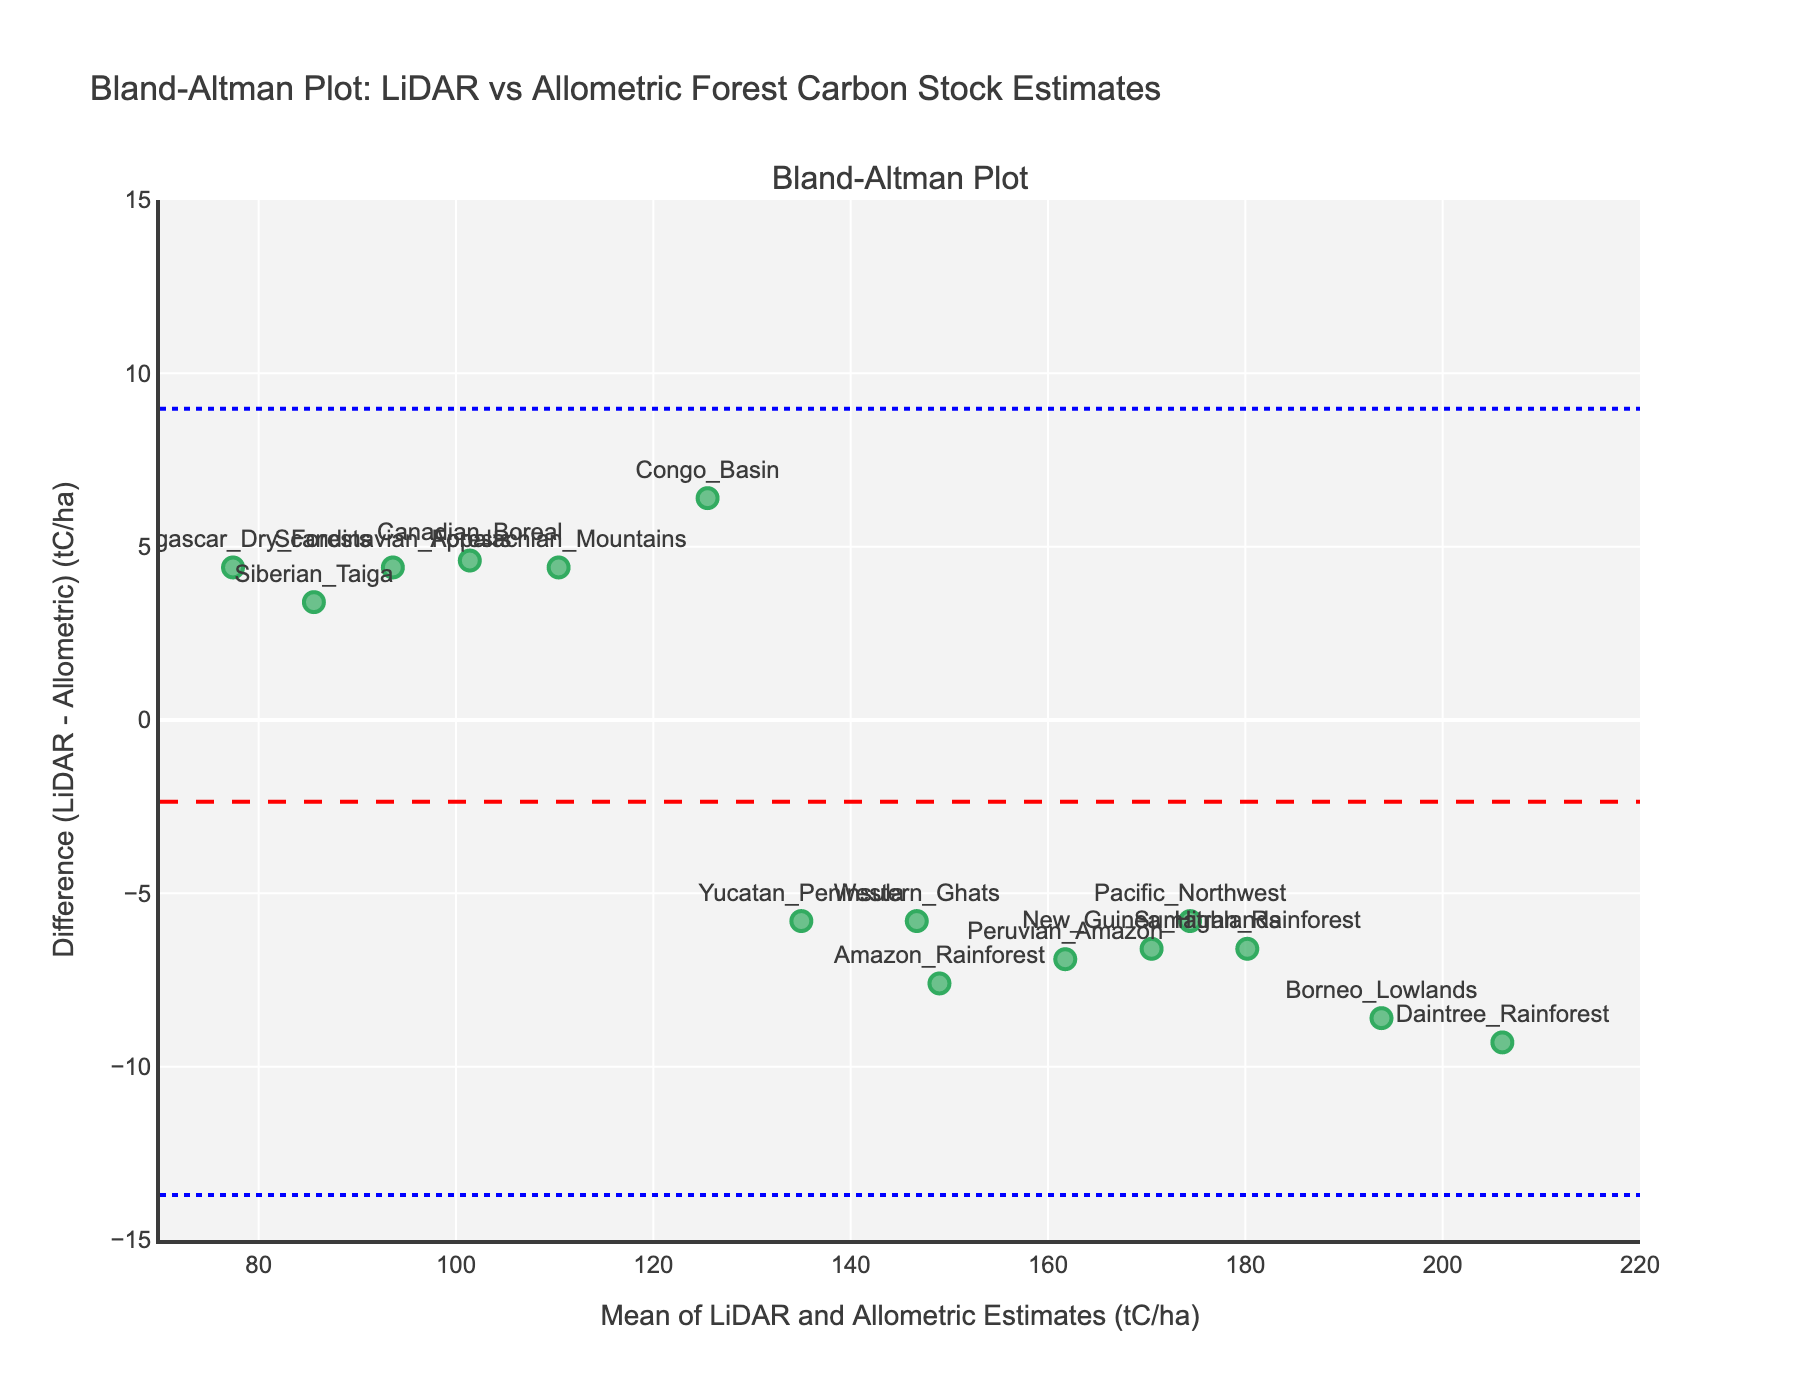How many data points are shown on the plot? Count the number of markers representing different forest locations on the plot. Each marker represents one data point.
Answer: 15 What is the title of the plot? Look at the text at the top of the plot. It's typically larger and bold to distinguish it as the title.
Answer: Bland-Altman Plot: LiDAR vs Allometric Forest Carbon Stock Estimates Which region has the highest mean value of LiDAR and Allometric estimates? Identify the x-axis positions of the markers. The marker farthest to the right on the x-axis has the highest mean value of LiDAR and Allometric estimates.
Answer: Daintree Rainforest What is the mean difference between LiDAR and Allometric estimates? Find the dashed red line on the y-axis. The value where this line intersects the y-axis is the mean difference.
Answer: Approximately -0.1 What are the upper and lower limits of agreement (LoA)? The dotted blue lines on the plot indicate the upper and lower limits of agreement. Read the y-axis values where these lines intersect.
Answer: Upper LoA: Approximately 5.9, Lower LoA: Approximately -6.1 Which forest region shows the largest positive difference between LiDAR and Allometric estimates? Identify the marker with the highest position above the x-axis, which indicates the largest positive difference.
Answer: Borneo Lowlands Which forest region shows the largest negative difference between LiDAR and Allometric estimates? Identify the marker with the lowest position below the x-axis, which indicates the largest negative difference.
Answer: Madagascar Dry Forests What is the average mean value of the methods (LiDAR and Allometric estimates) for the Amazon Rainforest and the Pacific Northwest? Calculate the mean value for Amazon Rainforest ((145.2 + 152.8) / 2) and for Pacific Northwest ((171.5 + 177.3) / 2), then find their average.
Answer: ((149.0 + 174.4) / 2) = 161.7 Is there any forest region where the LiDAR estimate is exactly equal to the Allometric estimate? Check the plot for any data point lying exactly on the x-axis where the difference would be zero.
Answer: No What is the range of mean values for all the data points? Identify the minimum and maximum x-axis values of the markers. The range is the difference between these two values.
Answer: Maximum: 206.05, Minimum: 77.4, Range: 128.65 